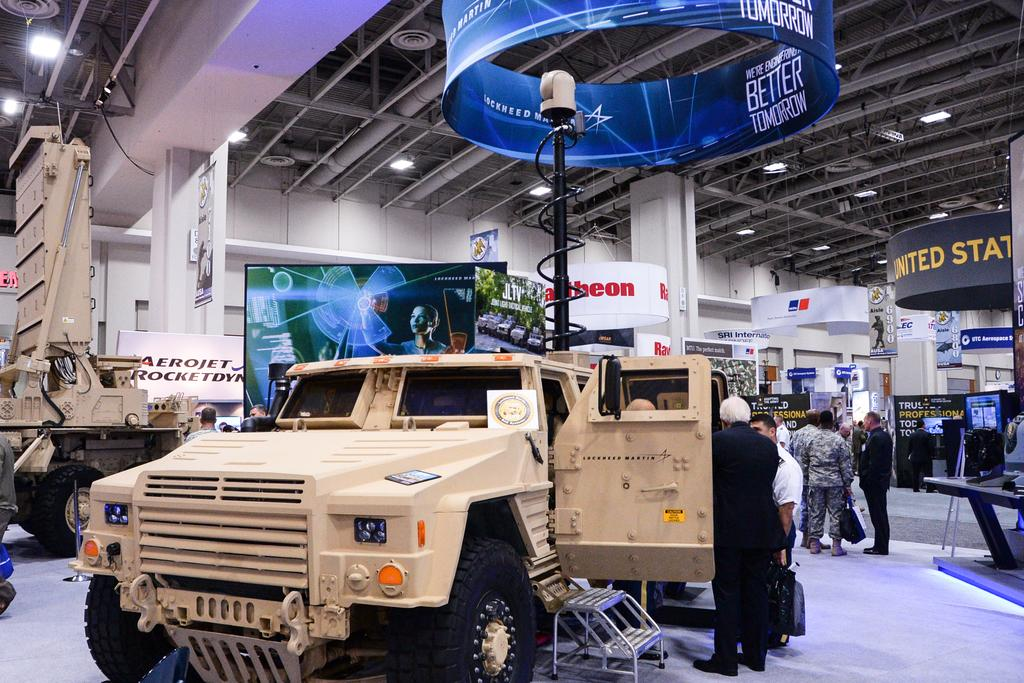How many people are in the group visible in the image? There is a group of people standing in the image, but the exact number cannot be determined from the provided facts. What type of vehicles are on the floor in the image? The facts do not specify the type of vehicles present on the floor. What architectural features can be seen in the background of the image? In the background of the image, there are posts, pillars, lights, rods, and a pole. Can you describe the lighting in the image? Lights are visible in the background of the image. What other objects are present in the background of the image? There are other objects in the background of the image, but their specific nature cannot be determined from the provided facts. Can you see any toes on the seashore in the image? There is no mention of a seashore or toes in the image, so this question cannot be answered definitively. 